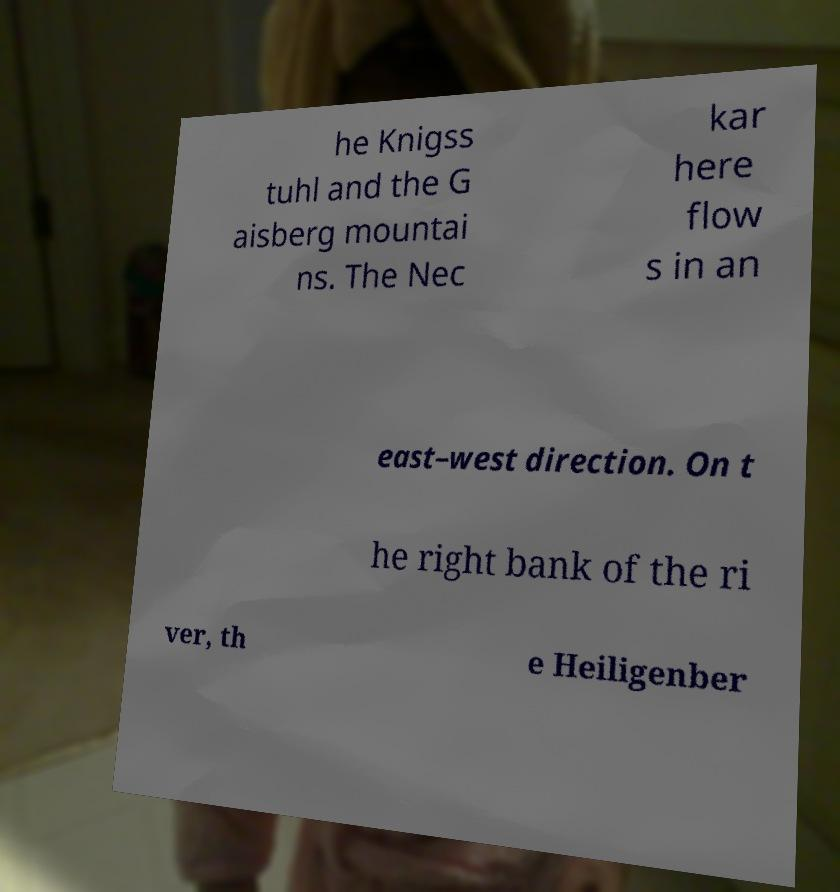There's text embedded in this image that I need extracted. Can you transcribe it verbatim? he Knigss tuhl and the G aisberg mountai ns. The Nec kar here flow s in an east–west direction. On t he right bank of the ri ver, th e Heiligenber 